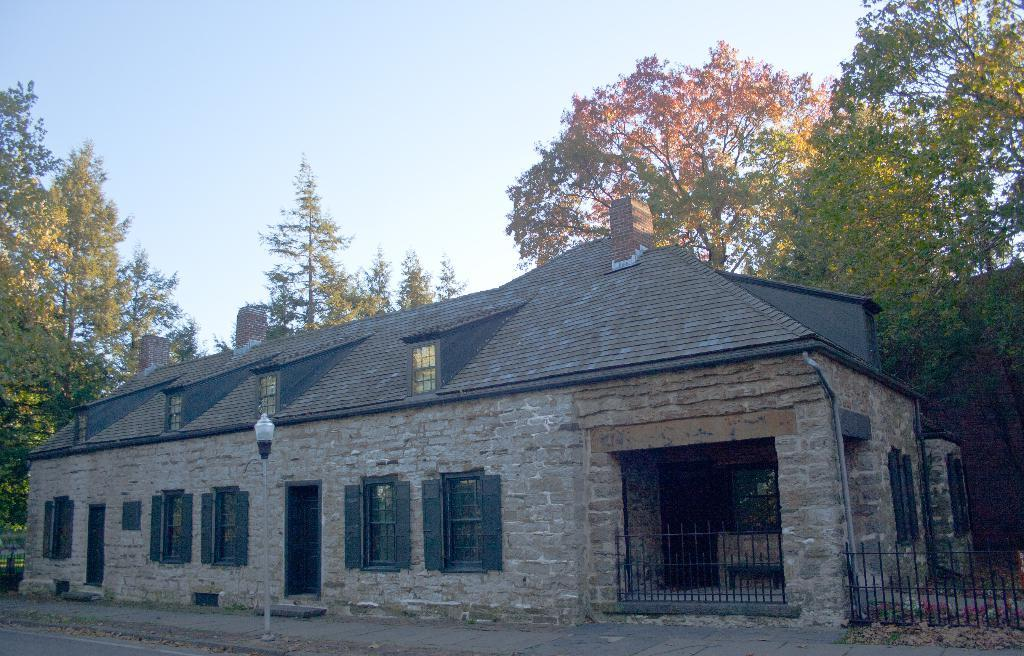What type of structure is present in the image? There is a house in the image. What features can be seen on the house? The house has windows and doors. What is located at the bottom of the image? There is a light pole at the bottom of the image. What can be seen in the background of the image? There are trees and the sky visible in the background of the image. What type of fuel is being used by the jail in the image? There is no jail present in the image, and therefore no fuel can be associated with it. 